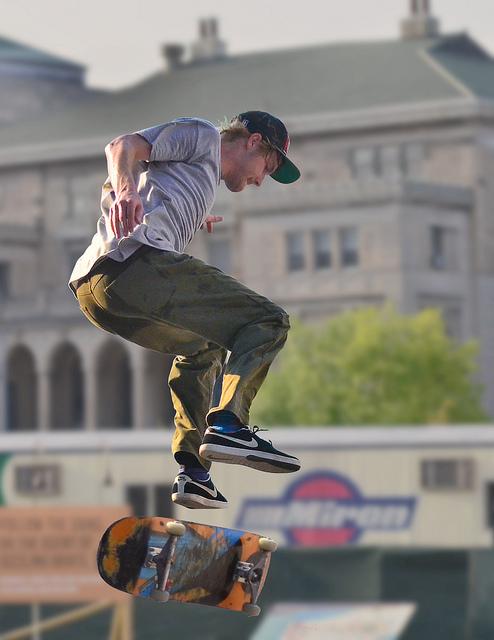Is he doing  trick?
Concise answer only. Yes. What brand of shoes does the man wear?
Give a very brief answer. Nike. Are all four wheels the same color?
Be succinct. Yes. Does the boarder wear a hat?
Answer briefly. Yes. 